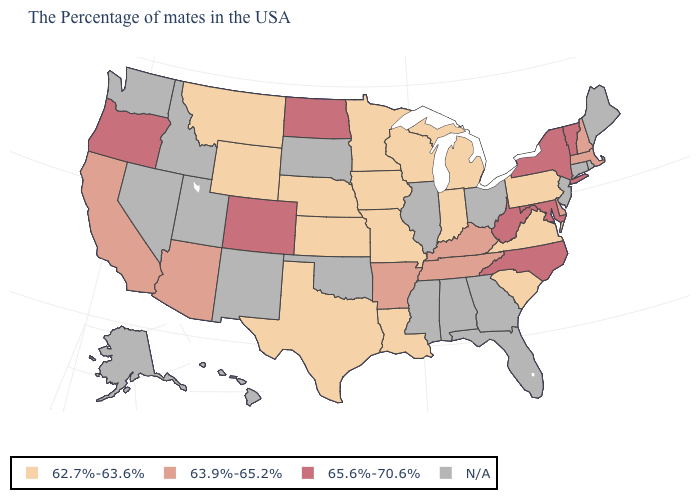Which states have the lowest value in the USA?
Quick response, please. Pennsylvania, Virginia, South Carolina, Michigan, Indiana, Wisconsin, Louisiana, Missouri, Minnesota, Iowa, Kansas, Nebraska, Texas, Wyoming, Montana. Which states hav the highest value in the West?
Concise answer only. Colorado, Oregon. How many symbols are there in the legend?
Give a very brief answer. 4. What is the value of New Hampshire?
Concise answer only. 63.9%-65.2%. Does the first symbol in the legend represent the smallest category?
Quick response, please. Yes. What is the highest value in states that border Oklahoma?
Write a very short answer. 65.6%-70.6%. Does Kansas have the highest value in the MidWest?
Answer briefly. No. Does the first symbol in the legend represent the smallest category?
Short answer required. Yes. Does the map have missing data?
Keep it brief. Yes. Name the states that have a value in the range 63.9%-65.2%?
Short answer required. Massachusetts, New Hampshire, Delaware, Kentucky, Tennessee, Arkansas, Arizona, California. Name the states that have a value in the range 63.9%-65.2%?
Quick response, please. Massachusetts, New Hampshire, Delaware, Kentucky, Tennessee, Arkansas, Arizona, California. Which states have the lowest value in the South?
Quick response, please. Virginia, South Carolina, Louisiana, Texas. What is the lowest value in the Northeast?
Quick response, please. 62.7%-63.6%. Does Oregon have the highest value in the USA?
Be succinct. Yes. Which states have the lowest value in the West?
Concise answer only. Wyoming, Montana. 